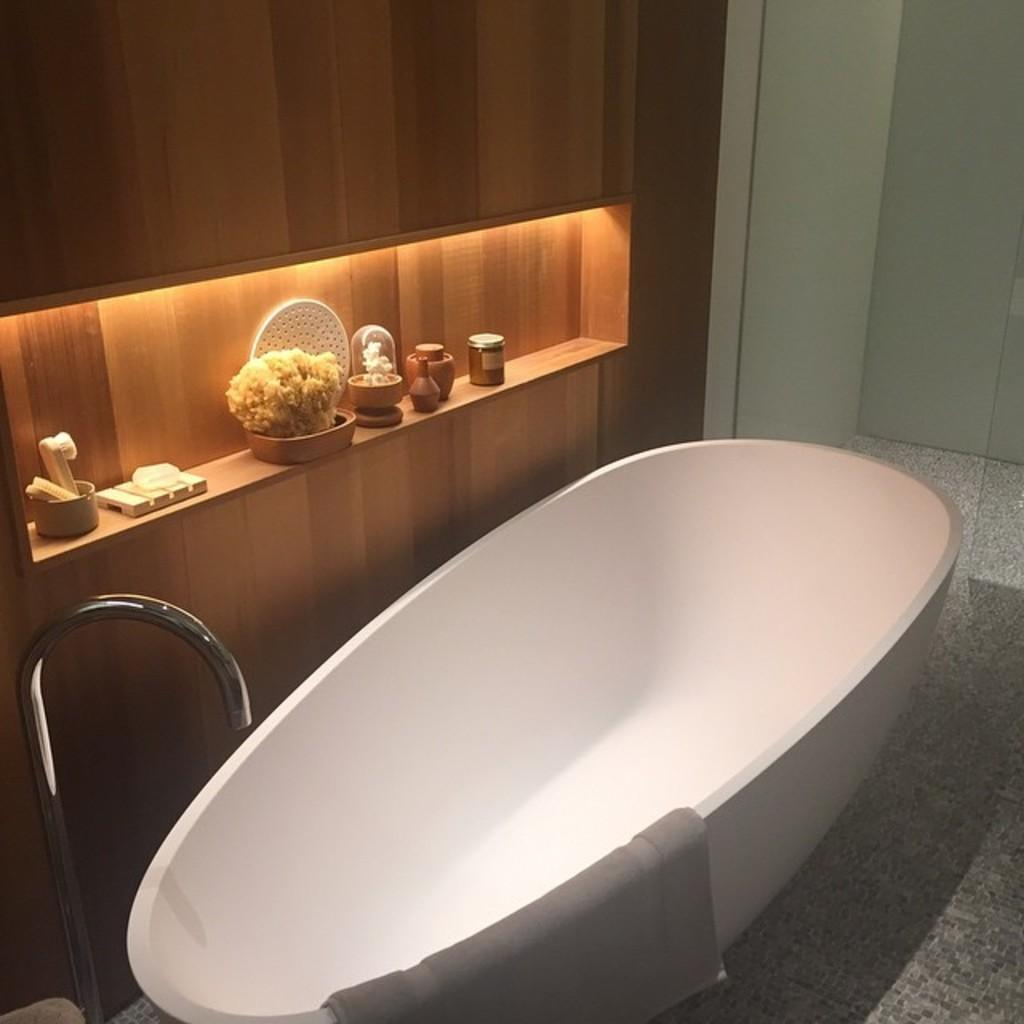What is the main object in the image? There is a bathtub in the image. What is inside the bathtub? There is cloth in the bathtub. Where does the water come from for the bathtub? There is a tap in the image. What type of wall is behind the bathtub? There is a wooden wall behind the bathtub. What is attached to the wooden wall? There is a cupboard on the wooden wall. What can be seen on the cupboard? There are items on the cupboard. How many clams are sitting on the wooden wall in the image? There are no clams present in the image. What type of society is depicted in the image? The image does not depict any society; it is a bathtub with a wooden wall and a cupboard. 